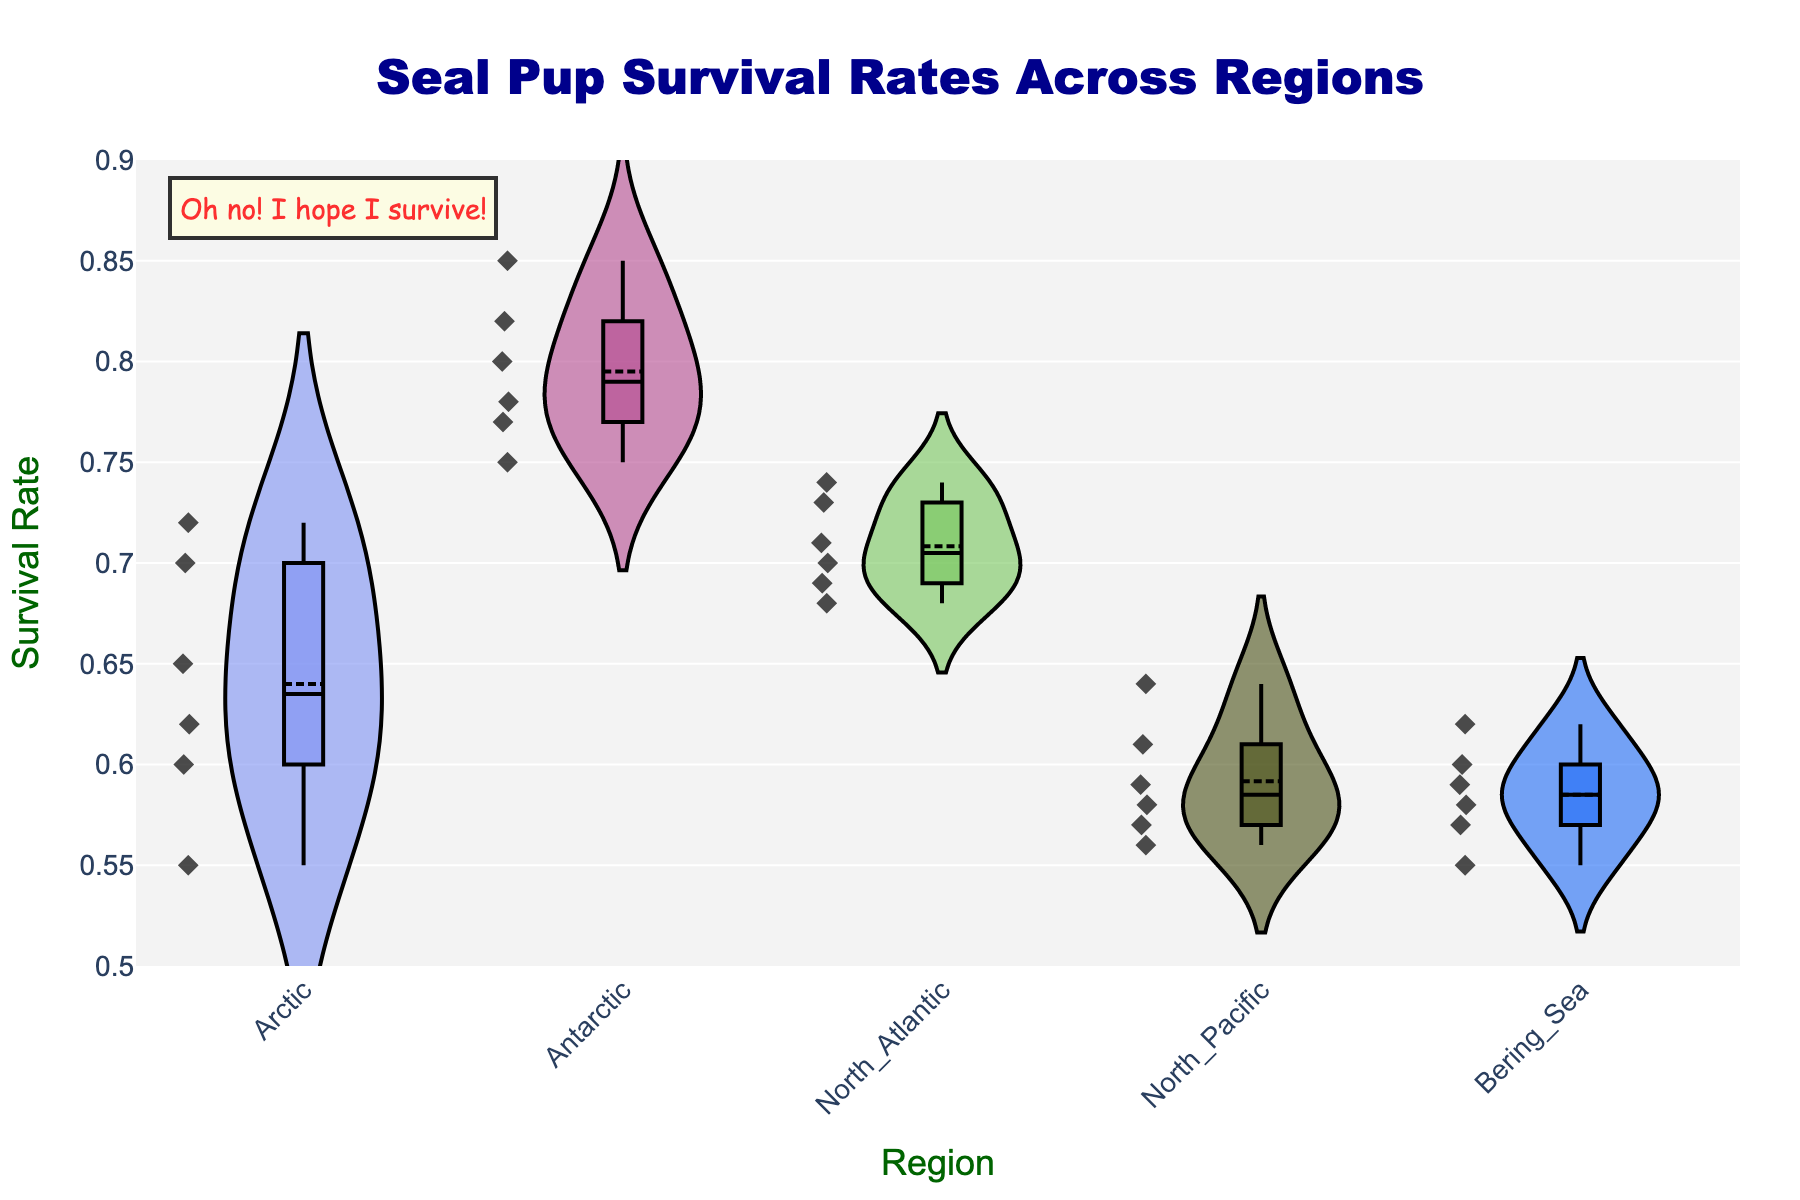What's the title of the figure? The title of a figure is located at the top and is often larger and more distinct in font. In this figure, it reads "Seal Pup Survival Rates Across Regions".
Answer: Seal Pup Survival Rates Across Regions What is the range of the y-axis? The range of the y-axis is often indicated at the sides, showing the minimum and maximum values. In this figure, the range of the y-axis is from 0.5 to 0.9.
Answer: 0.5 to 0.9 Which region shows the highest median survival rate for seal pups? To find the median survival rate for each region, look for the line within each box plot on the violin chart. The Antarctic region's median line is higher than the other regions.
Answer: Antarctic Which region has the lowest survival rate for seal pups? Observe the lowest points of each violin plot to identify the minimum survival rates. The North Pacific shows the lowest point among all regions.
Answer: North Pacific How many regions are represented in the figure? Count the number of distinct boxes or violins in the plot, each representing a different region.
Answer: 5 What is the survival rate for the North Atlantic region's highest data point? Check the highest data point within the North Atlantic section of the chart. It reaches up to 0.74.
Answer: 0.74 Which region has more variability in survival rates, Arctic or Bering Sea? More variability means a wider spread or range in the survival rates. Compare the width of the violin plots for the Arctic and Bering Sea. The Arctic has a wider spread, indicating more variability.
Answer: Arctic How does the median survival rate in the North Pacific compare to that in the Arctic? Compare the median lines within the box plots for both regions. The North Pacific's median is lower than the Arctic’s median survival rate.
Answer: North Pacific is lower What is the color of the fill for the Antarctic region? Each region has a distinct color fill in the violin plot. The Antarctic region has a unique color, visible in the chart.
Answer: (Specific color can only be identified visually; describe based on appearance in the figure) Is there a region where all data points lie above 0.60 survival rate? Look at the individual data points within each violin plot. The Antarctic is the region where all survival rates are above 0.60.
Answer: Antarctic 